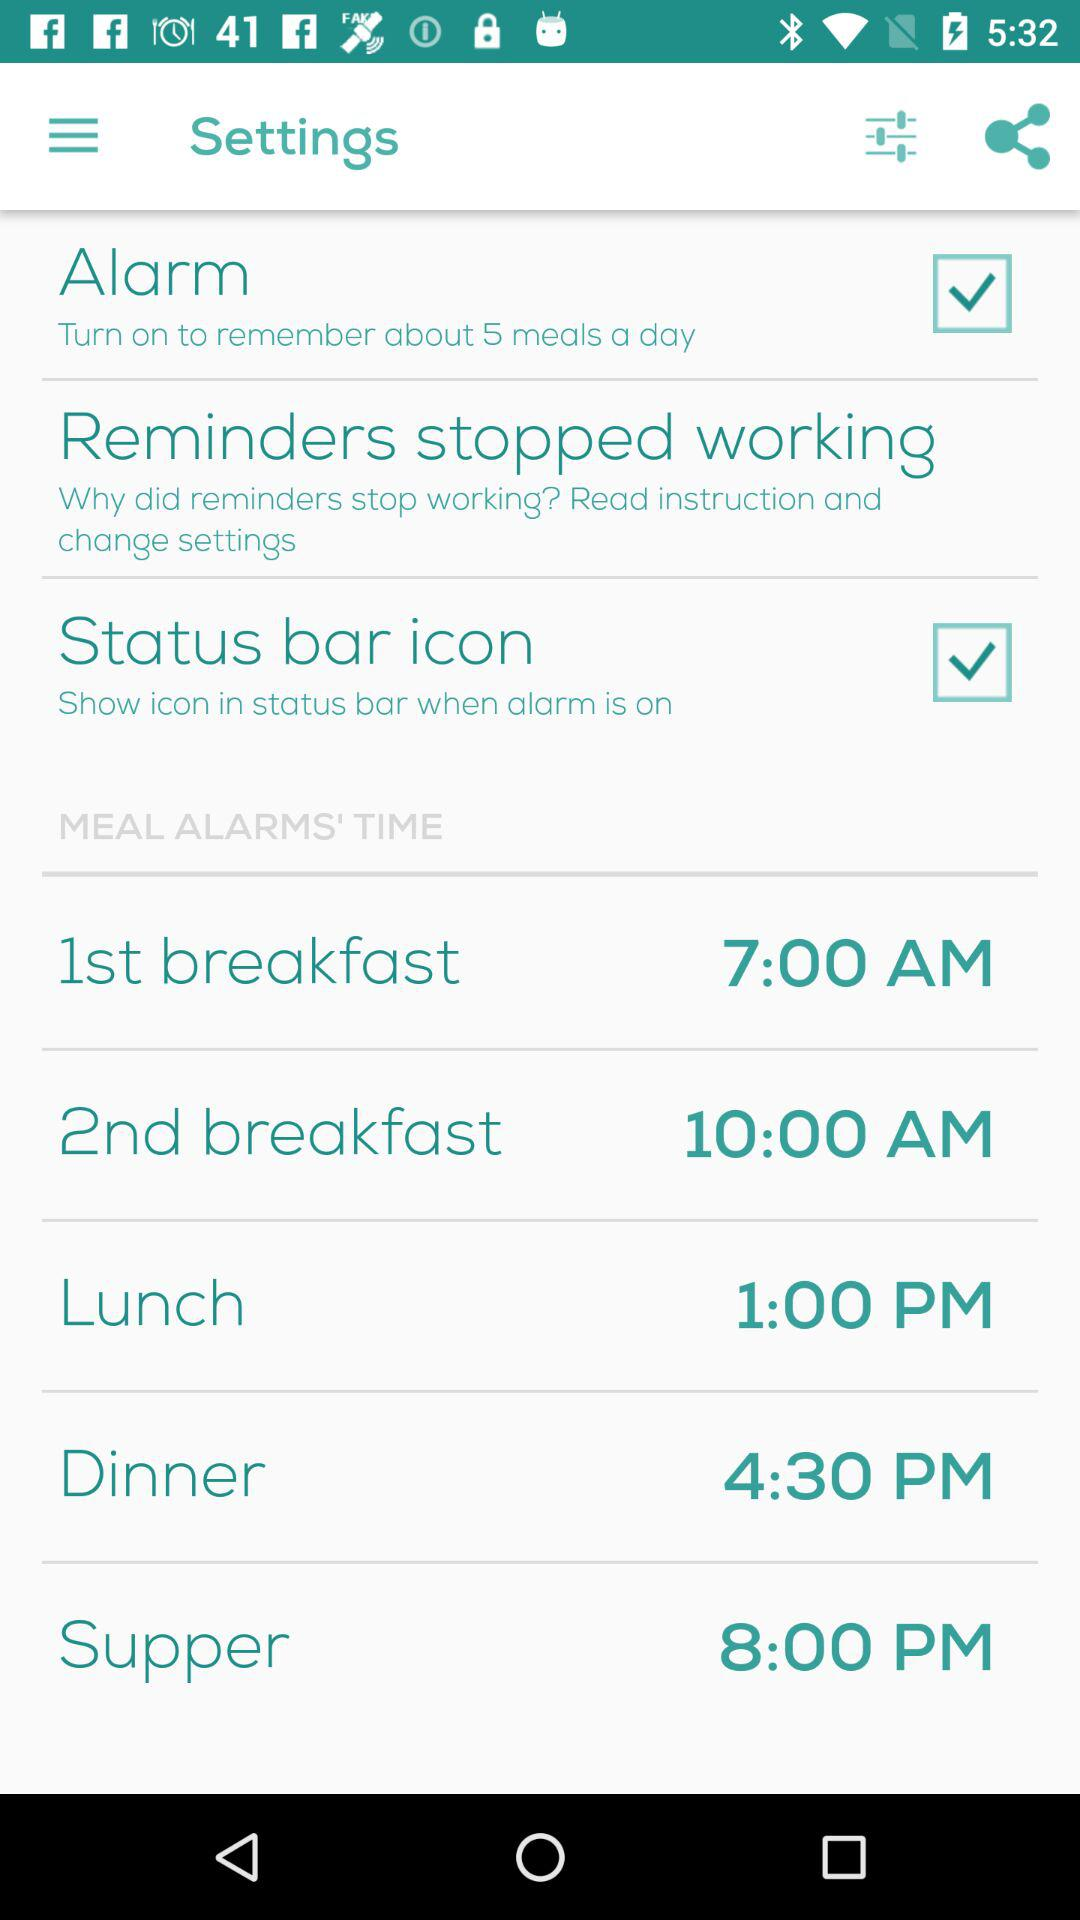How many meal alarms are there?
Answer the question using a single word or phrase. 5 